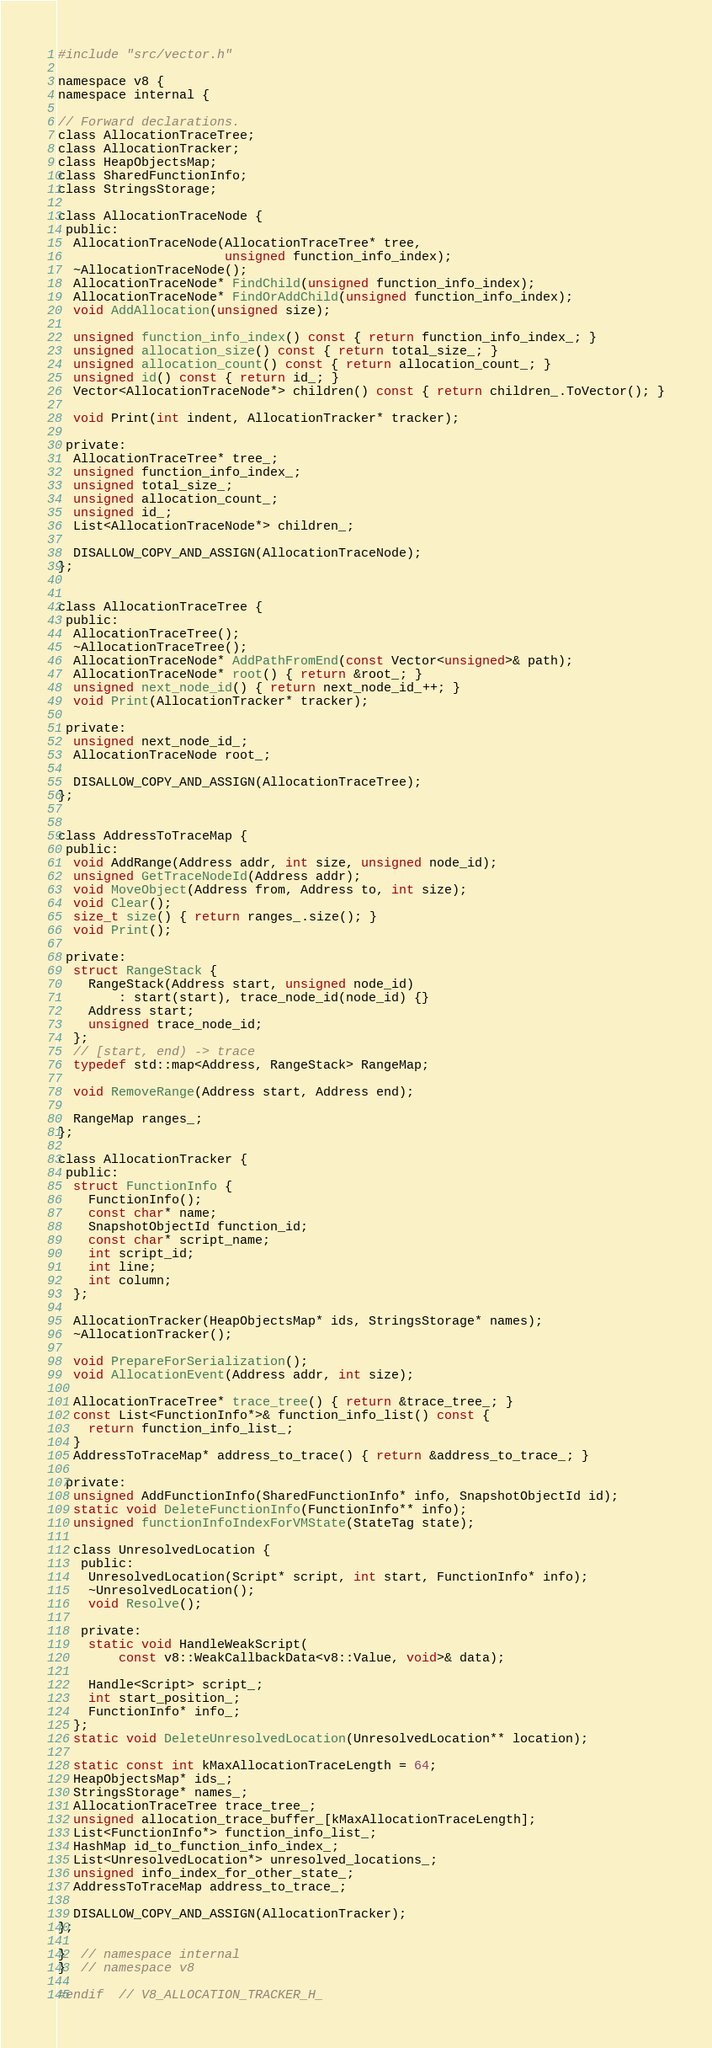<code> <loc_0><loc_0><loc_500><loc_500><_C_>#include "src/vector.h"

namespace v8 {
namespace internal {

// Forward declarations.
class AllocationTraceTree;
class AllocationTracker;
class HeapObjectsMap;
class SharedFunctionInfo;
class StringsStorage;

class AllocationTraceNode {
 public:
  AllocationTraceNode(AllocationTraceTree* tree,
                      unsigned function_info_index);
  ~AllocationTraceNode();
  AllocationTraceNode* FindChild(unsigned function_info_index);
  AllocationTraceNode* FindOrAddChild(unsigned function_info_index);
  void AddAllocation(unsigned size);

  unsigned function_info_index() const { return function_info_index_; }
  unsigned allocation_size() const { return total_size_; }
  unsigned allocation_count() const { return allocation_count_; }
  unsigned id() const { return id_; }
  Vector<AllocationTraceNode*> children() const { return children_.ToVector(); }

  void Print(int indent, AllocationTracker* tracker);

 private:
  AllocationTraceTree* tree_;
  unsigned function_info_index_;
  unsigned total_size_;
  unsigned allocation_count_;
  unsigned id_;
  List<AllocationTraceNode*> children_;

  DISALLOW_COPY_AND_ASSIGN(AllocationTraceNode);
};


class AllocationTraceTree {
 public:
  AllocationTraceTree();
  ~AllocationTraceTree();
  AllocationTraceNode* AddPathFromEnd(const Vector<unsigned>& path);
  AllocationTraceNode* root() { return &root_; }
  unsigned next_node_id() { return next_node_id_++; }
  void Print(AllocationTracker* tracker);

 private:
  unsigned next_node_id_;
  AllocationTraceNode root_;

  DISALLOW_COPY_AND_ASSIGN(AllocationTraceTree);
};


class AddressToTraceMap {
 public:
  void AddRange(Address addr, int size, unsigned node_id);
  unsigned GetTraceNodeId(Address addr);
  void MoveObject(Address from, Address to, int size);
  void Clear();
  size_t size() { return ranges_.size(); }
  void Print();

 private:
  struct RangeStack {
    RangeStack(Address start, unsigned node_id)
        : start(start), trace_node_id(node_id) {}
    Address start;
    unsigned trace_node_id;
  };
  // [start, end) -> trace
  typedef std::map<Address, RangeStack> RangeMap;

  void RemoveRange(Address start, Address end);

  RangeMap ranges_;
};

class AllocationTracker {
 public:
  struct FunctionInfo {
    FunctionInfo();
    const char* name;
    SnapshotObjectId function_id;
    const char* script_name;
    int script_id;
    int line;
    int column;
  };

  AllocationTracker(HeapObjectsMap* ids, StringsStorage* names);
  ~AllocationTracker();

  void PrepareForSerialization();
  void AllocationEvent(Address addr, int size);

  AllocationTraceTree* trace_tree() { return &trace_tree_; }
  const List<FunctionInfo*>& function_info_list() const {
    return function_info_list_;
  }
  AddressToTraceMap* address_to_trace() { return &address_to_trace_; }

 private:
  unsigned AddFunctionInfo(SharedFunctionInfo* info, SnapshotObjectId id);
  static void DeleteFunctionInfo(FunctionInfo** info);
  unsigned functionInfoIndexForVMState(StateTag state);

  class UnresolvedLocation {
   public:
    UnresolvedLocation(Script* script, int start, FunctionInfo* info);
    ~UnresolvedLocation();
    void Resolve();

   private:
    static void HandleWeakScript(
        const v8::WeakCallbackData<v8::Value, void>& data);

    Handle<Script> script_;
    int start_position_;
    FunctionInfo* info_;
  };
  static void DeleteUnresolvedLocation(UnresolvedLocation** location);

  static const int kMaxAllocationTraceLength = 64;
  HeapObjectsMap* ids_;
  StringsStorage* names_;
  AllocationTraceTree trace_tree_;
  unsigned allocation_trace_buffer_[kMaxAllocationTraceLength];
  List<FunctionInfo*> function_info_list_;
  HashMap id_to_function_info_index_;
  List<UnresolvedLocation*> unresolved_locations_;
  unsigned info_index_for_other_state_;
  AddressToTraceMap address_to_trace_;

  DISALLOW_COPY_AND_ASSIGN(AllocationTracker);
};

}  // namespace internal
}  // namespace v8

#endif  // V8_ALLOCATION_TRACKER_H_
</code> 